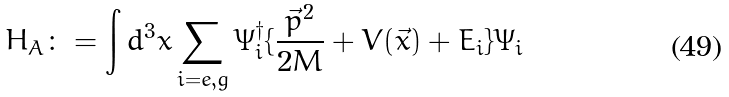Convert formula to latex. <formula><loc_0><loc_0><loc_500><loc_500>H _ { A } \colon = \int d ^ { 3 } x \sum _ { i = e , g } \Psi _ { i } ^ { \dagger } \{ \frac { \vec { p } ^ { 2 } } { 2 M } + V ( \vec { x } ) + E _ { i } \} \Psi _ { i }</formula> 